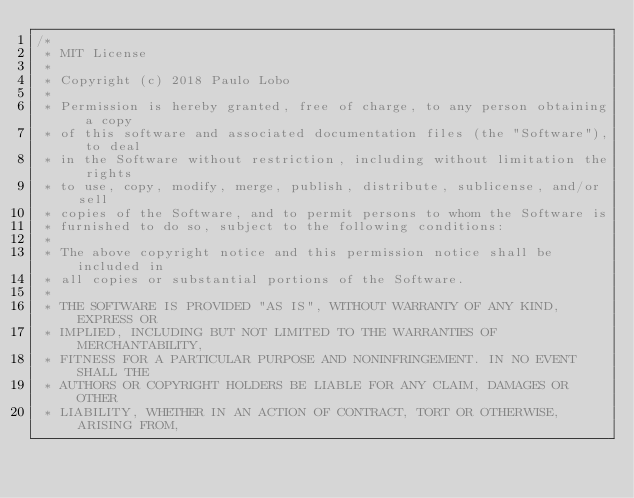<code> <loc_0><loc_0><loc_500><loc_500><_Java_>/*
 * MIT License
 *
 * Copyright (c) 2018 Paulo Lobo
 *
 * Permission is hereby granted, free of charge, to any person obtaining a copy
 * of this software and associated documentation files (the "Software"), to deal
 * in the Software without restriction, including without limitation the rights
 * to use, copy, modify, merge, publish, distribute, sublicense, and/or sell
 * copies of the Software, and to permit persons to whom the Software is
 * furnished to do so, subject to the following conditions:
 *
 * The above copyright notice and this permission notice shall be included in
 * all copies or substantial portions of the Software.
 *
 * THE SOFTWARE IS PROVIDED "AS IS", WITHOUT WARRANTY OF ANY KIND, EXPRESS OR
 * IMPLIED, INCLUDING BUT NOT LIMITED TO THE WARRANTIES OF MERCHANTABILITY,
 * FITNESS FOR A PARTICULAR PURPOSE AND NONINFRINGEMENT. IN NO EVENT SHALL THE
 * AUTHORS OR COPYRIGHT HOLDERS BE LIABLE FOR ANY CLAIM, DAMAGES OR OTHER
 * LIABILITY, WHETHER IN AN ACTION OF CONTRACT, TORT OR OTHERWISE, ARISING FROM,</code> 